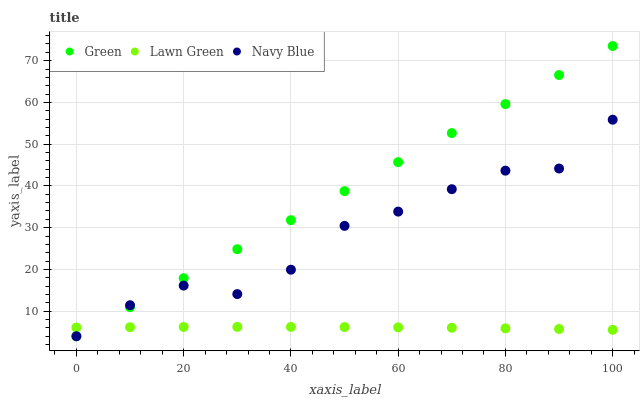Does Lawn Green have the minimum area under the curve?
Answer yes or no. Yes. Does Green have the maximum area under the curve?
Answer yes or no. Yes. Does Navy Blue have the minimum area under the curve?
Answer yes or no. No. Does Navy Blue have the maximum area under the curve?
Answer yes or no. No. Is Green the smoothest?
Answer yes or no. Yes. Is Navy Blue the roughest?
Answer yes or no. Yes. Is Navy Blue the smoothest?
Answer yes or no. No. Is Green the roughest?
Answer yes or no. No. Does Green have the lowest value?
Answer yes or no. Yes. Does Green have the highest value?
Answer yes or no. Yes. Does Navy Blue have the highest value?
Answer yes or no. No. Does Green intersect Lawn Green?
Answer yes or no. Yes. Is Green less than Lawn Green?
Answer yes or no. No. Is Green greater than Lawn Green?
Answer yes or no. No. 